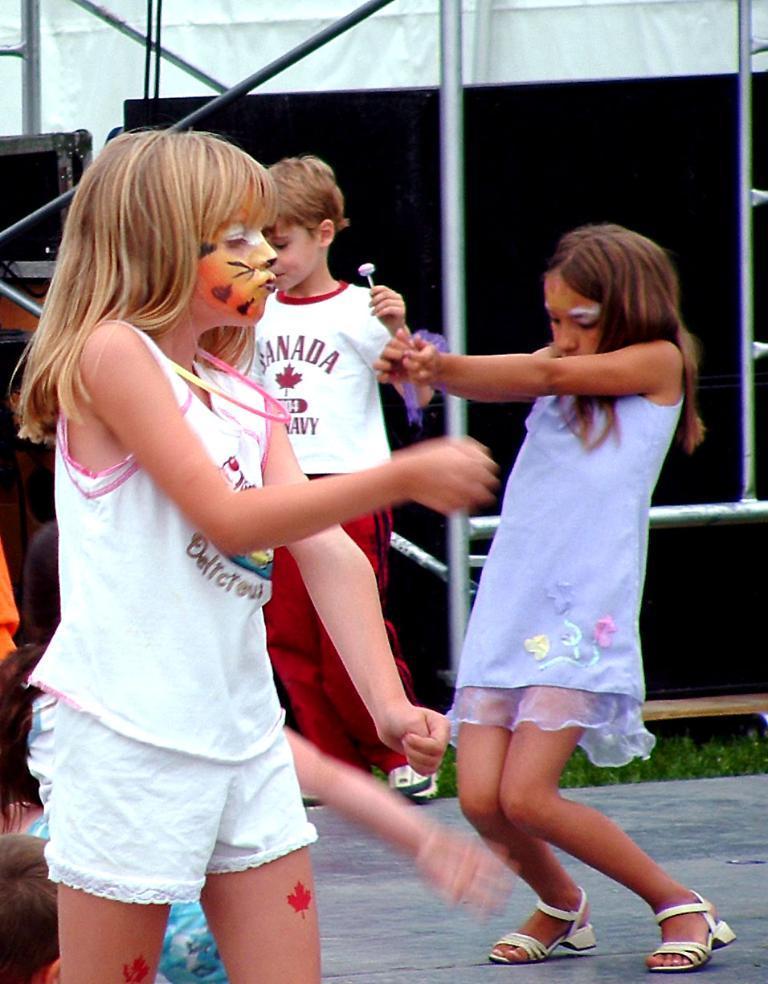How would you summarize this image in a sentence or two? This image is taken outdoors. At the bottom of the image there is a floor. In the background there is a speaker box and iron bars. In the middle of the image a few kids are playing on the floor. 